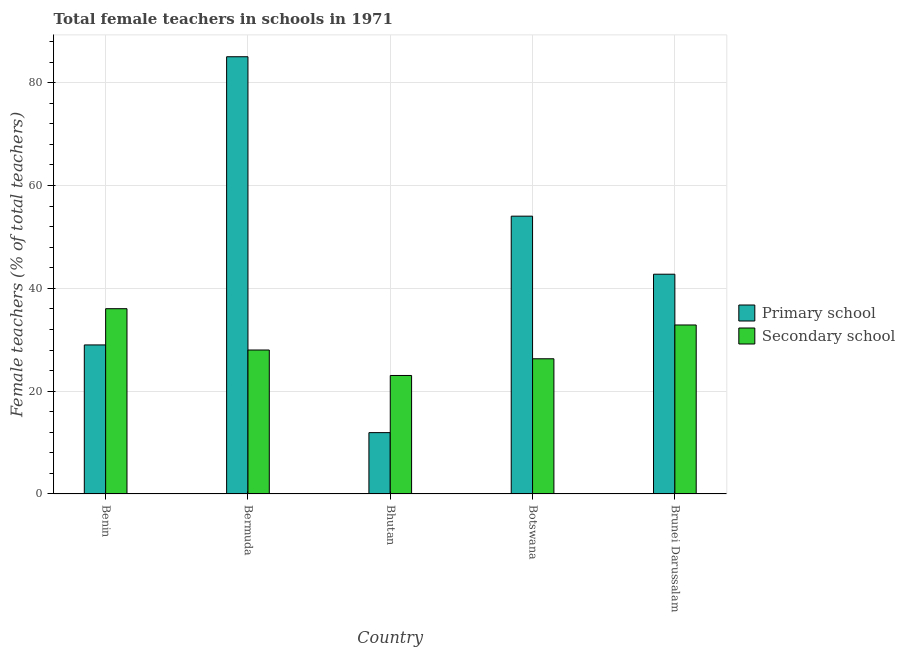How many different coloured bars are there?
Offer a very short reply. 2. What is the label of the 5th group of bars from the left?
Offer a terse response. Brunei Darussalam. What is the percentage of female teachers in secondary schools in Brunei Darussalam?
Your answer should be compact. 32.87. Across all countries, what is the maximum percentage of female teachers in primary schools?
Ensure brevity in your answer.  85.04. Across all countries, what is the minimum percentage of female teachers in primary schools?
Offer a terse response. 11.93. In which country was the percentage of female teachers in primary schools maximum?
Ensure brevity in your answer.  Bermuda. In which country was the percentage of female teachers in primary schools minimum?
Make the answer very short. Bhutan. What is the total percentage of female teachers in secondary schools in the graph?
Your answer should be compact. 146.25. What is the difference between the percentage of female teachers in secondary schools in Bermuda and that in Bhutan?
Your answer should be very brief. 4.95. What is the difference between the percentage of female teachers in secondary schools in Botswana and the percentage of female teachers in primary schools in Bhutan?
Keep it short and to the point. 14.37. What is the average percentage of female teachers in secondary schools per country?
Provide a succinct answer. 29.25. What is the difference between the percentage of female teachers in secondary schools and percentage of female teachers in primary schools in Benin?
Keep it short and to the point. 7.05. What is the ratio of the percentage of female teachers in primary schools in Benin to that in Bermuda?
Your answer should be compact. 0.34. Is the difference between the percentage of female teachers in secondary schools in Bhutan and Brunei Darussalam greater than the difference between the percentage of female teachers in primary schools in Bhutan and Brunei Darussalam?
Your answer should be very brief. Yes. What is the difference between the highest and the second highest percentage of female teachers in primary schools?
Make the answer very short. 31.01. What is the difference between the highest and the lowest percentage of female teachers in secondary schools?
Make the answer very short. 12.99. What does the 1st bar from the left in Brunei Darussalam represents?
Provide a short and direct response. Primary school. What does the 2nd bar from the right in Benin represents?
Keep it short and to the point. Primary school. Are all the bars in the graph horizontal?
Your answer should be very brief. No. How many countries are there in the graph?
Your answer should be compact. 5. What is the difference between two consecutive major ticks on the Y-axis?
Your answer should be very brief. 20. Does the graph contain grids?
Your answer should be compact. Yes. What is the title of the graph?
Provide a short and direct response. Total female teachers in schools in 1971. What is the label or title of the X-axis?
Your answer should be compact. Country. What is the label or title of the Y-axis?
Provide a succinct answer. Female teachers (% of total teachers). What is the Female teachers (% of total teachers) in Primary school in Benin?
Your response must be concise. 28.99. What is the Female teachers (% of total teachers) of Secondary school in Benin?
Give a very brief answer. 36.04. What is the Female teachers (% of total teachers) in Primary school in Bermuda?
Your answer should be compact. 85.04. What is the Female teachers (% of total teachers) in Secondary school in Bermuda?
Your response must be concise. 28. What is the Female teachers (% of total teachers) of Primary school in Bhutan?
Keep it short and to the point. 11.93. What is the Female teachers (% of total teachers) in Secondary school in Bhutan?
Offer a terse response. 23.05. What is the Female teachers (% of total teachers) of Primary school in Botswana?
Offer a terse response. 54.03. What is the Female teachers (% of total teachers) in Secondary school in Botswana?
Your answer should be very brief. 26.3. What is the Female teachers (% of total teachers) in Primary school in Brunei Darussalam?
Your answer should be compact. 42.75. What is the Female teachers (% of total teachers) in Secondary school in Brunei Darussalam?
Make the answer very short. 32.87. Across all countries, what is the maximum Female teachers (% of total teachers) in Primary school?
Your response must be concise. 85.04. Across all countries, what is the maximum Female teachers (% of total teachers) in Secondary school?
Provide a succinct answer. 36.04. Across all countries, what is the minimum Female teachers (% of total teachers) in Primary school?
Give a very brief answer. 11.93. Across all countries, what is the minimum Female teachers (% of total teachers) in Secondary school?
Offer a terse response. 23.05. What is the total Female teachers (% of total teachers) in Primary school in the graph?
Your response must be concise. 222.75. What is the total Female teachers (% of total teachers) of Secondary school in the graph?
Provide a short and direct response. 146.25. What is the difference between the Female teachers (% of total teachers) of Primary school in Benin and that in Bermuda?
Provide a short and direct response. -56.05. What is the difference between the Female teachers (% of total teachers) in Secondary school in Benin and that in Bermuda?
Ensure brevity in your answer.  8.04. What is the difference between the Female teachers (% of total teachers) in Primary school in Benin and that in Bhutan?
Ensure brevity in your answer.  17.06. What is the difference between the Female teachers (% of total teachers) in Secondary school in Benin and that in Bhutan?
Provide a succinct answer. 12.99. What is the difference between the Female teachers (% of total teachers) of Primary school in Benin and that in Botswana?
Provide a short and direct response. -25.04. What is the difference between the Female teachers (% of total teachers) in Secondary school in Benin and that in Botswana?
Your answer should be compact. 9.74. What is the difference between the Female teachers (% of total teachers) in Primary school in Benin and that in Brunei Darussalam?
Your answer should be compact. -13.76. What is the difference between the Female teachers (% of total teachers) in Secondary school in Benin and that in Brunei Darussalam?
Offer a very short reply. 3.17. What is the difference between the Female teachers (% of total teachers) of Primary school in Bermuda and that in Bhutan?
Your answer should be compact. 73.11. What is the difference between the Female teachers (% of total teachers) of Secondary school in Bermuda and that in Bhutan?
Your answer should be very brief. 4.95. What is the difference between the Female teachers (% of total teachers) in Primary school in Bermuda and that in Botswana?
Your answer should be very brief. 31.01. What is the difference between the Female teachers (% of total teachers) in Secondary school in Bermuda and that in Botswana?
Your response must be concise. 1.71. What is the difference between the Female teachers (% of total teachers) in Primary school in Bermuda and that in Brunei Darussalam?
Offer a very short reply. 42.3. What is the difference between the Female teachers (% of total teachers) of Secondary school in Bermuda and that in Brunei Darussalam?
Your answer should be compact. -4.87. What is the difference between the Female teachers (% of total teachers) in Primary school in Bhutan and that in Botswana?
Offer a very short reply. -42.1. What is the difference between the Female teachers (% of total teachers) in Secondary school in Bhutan and that in Botswana?
Offer a very short reply. -3.25. What is the difference between the Female teachers (% of total teachers) of Primary school in Bhutan and that in Brunei Darussalam?
Offer a very short reply. -30.81. What is the difference between the Female teachers (% of total teachers) in Secondary school in Bhutan and that in Brunei Darussalam?
Offer a very short reply. -9.82. What is the difference between the Female teachers (% of total teachers) of Primary school in Botswana and that in Brunei Darussalam?
Your answer should be very brief. 11.29. What is the difference between the Female teachers (% of total teachers) of Secondary school in Botswana and that in Brunei Darussalam?
Provide a succinct answer. -6.57. What is the difference between the Female teachers (% of total teachers) in Primary school in Benin and the Female teachers (% of total teachers) in Secondary school in Bermuda?
Your response must be concise. 0.99. What is the difference between the Female teachers (% of total teachers) in Primary school in Benin and the Female teachers (% of total teachers) in Secondary school in Bhutan?
Your answer should be compact. 5.94. What is the difference between the Female teachers (% of total teachers) in Primary school in Benin and the Female teachers (% of total teachers) in Secondary school in Botswana?
Your answer should be compact. 2.69. What is the difference between the Female teachers (% of total teachers) of Primary school in Benin and the Female teachers (% of total teachers) of Secondary school in Brunei Darussalam?
Your answer should be compact. -3.88. What is the difference between the Female teachers (% of total teachers) of Primary school in Bermuda and the Female teachers (% of total teachers) of Secondary school in Bhutan?
Provide a succinct answer. 62. What is the difference between the Female teachers (% of total teachers) of Primary school in Bermuda and the Female teachers (% of total teachers) of Secondary school in Botswana?
Provide a short and direct response. 58.75. What is the difference between the Female teachers (% of total teachers) of Primary school in Bermuda and the Female teachers (% of total teachers) of Secondary school in Brunei Darussalam?
Offer a very short reply. 52.17. What is the difference between the Female teachers (% of total teachers) of Primary school in Bhutan and the Female teachers (% of total teachers) of Secondary school in Botswana?
Provide a succinct answer. -14.37. What is the difference between the Female teachers (% of total teachers) of Primary school in Bhutan and the Female teachers (% of total teachers) of Secondary school in Brunei Darussalam?
Your answer should be very brief. -20.94. What is the difference between the Female teachers (% of total teachers) of Primary school in Botswana and the Female teachers (% of total teachers) of Secondary school in Brunei Darussalam?
Keep it short and to the point. 21.16. What is the average Female teachers (% of total teachers) of Primary school per country?
Your answer should be very brief. 44.55. What is the average Female teachers (% of total teachers) in Secondary school per country?
Give a very brief answer. 29.25. What is the difference between the Female teachers (% of total teachers) of Primary school and Female teachers (% of total teachers) of Secondary school in Benin?
Offer a very short reply. -7.05. What is the difference between the Female teachers (% of total teachers) of Primary school and Female teachers (% of total teachers) of Secondary school in Bermuda?
Keep it short and to the point. 57.04. What is the difference between the Female teachers (% of total teachers) of Primary school and Female teachers (% of total teachers) of Secondary school in Bhutan?
Give a very brief answer. -11.12. What is the difference between the Female teachers (% of total teachers) of Primary school and Female teachers (% of total teachers) of Secondary school in Botswana?
Keep it short and to the point. 27.74. What is the difference between the Female teachers (% of total teachers) in Primary school and Female teachers (% of total teachers) in Secondary school in Brunei Darussalam?
Offer a terse response. 9.87. What is the ratio of the Female teachers (% of total teachers) in Primary school in Benin to that in Bermuda?
Provide a succinct answer. 0.34. What is the ratio of the Female teachers (% of total teachers) in Secondary school in Benin to that in Bermuda?
Your answer should be compact. 1.29. What is the ratio of the Female teachers (% of total teachers) in Primary school in Benin to that in Bhutan?
Give a very brief answer. 2.43. What is the ratio of the Female teachers (% of total teachers) of Secondary school in Benin to that in Bhutan?
Give a very brief answer. 1.56. What is the ratio of the Female teachers (% of total teachers) in Primary school in Benin to that in Botswana?
Provide a short and direct response. 0.54. What is the ratio of the Female teachers (% of total teachers) in Secondary school in Benin to that in Botswana?
Your answer should be very brief. 1.37. What is the ratio of the Female teachers (% of total teachers) in Primary school in Benin to that in Brunei Darussalam?
Keep it short and to the point. 0.68. What is the ratio of the Female teachers (% of total teachers) of Secondary school in Benin to that in Brunei Darussalam?
Offer a very short reply. 1.1. What is the ratio of the Female teachers (% of total teachers) in Primary school in Bermuda to that in Bhutan?
Give a very brief answer. 7.13. What is the ratio of the Female teachers (% of total teachers) of Secondary school in Bermuda to that in Bhutan?
Ensure brevity in your answer.  1.22. What is the ratio of the Female teachers (% of total teachers) of Primary school in Bermuda to that in Botswana?
Your response must be concise. 1.57. What is the ratio of the Female teachers (% of total teachers) in Secondary school in Bermuda to that in Botswana?
Give a very brief answer. 1.06. What is the ratio of the Female teachers (% of total teachers) in Primary school in Bermuda to that in Brunei Darussalam?
Your answer should be compact. 1.99. What is the ratio of the Female teachers (% of total teachers) of Secondary school in Bermuda to that in Brunei Darussalam?
Provide a succinct answer. 0.85. What is the ratio of the Female teachers (% of total teachers) of Primary school in Bhutan to that in Botswana?
Keep it short and to the point. 0.22. What is the ratio of the Female teachers (% of total teachers) in Secondary school in Bhutan to that in Botswana?
Make the answer very short. 0.88. What is the ratio of the Female teachers (% of total teachers) of Primary school in Bhutan to that in Brunei Darussalam?
Your answer should be compact. 0.28. What is the ratio of the Female teachers (% of total teachers) of Secondary school in Bhutan to that in Brunei Darussalam?
Offer a terse response. 0.7. What is the ratio of the Female teachers (% of total teachers) in Primary school in Botswana to that in Brunei Darussalam?
Ensure brevity in your answer.  1.26. What is the difference between the highest and the second highest Female teachers (% of total teachers) of Primary school?
Ensure brevity in your answer.  31.01. What is the difference between the highest and the second highest Female teachers (% of total teachers) of Secondary school?
Offer a very short reply. 3.17. What is the difference between the highest and the lowest Female teachers (% of total teachers) in Primary school?
Ensure brevity in your answer.  73.11. What is the difference between the highest and the lowest Female teachers (% of total teachers) in Secondary school?
Your answer should be very brief. 12.99. 